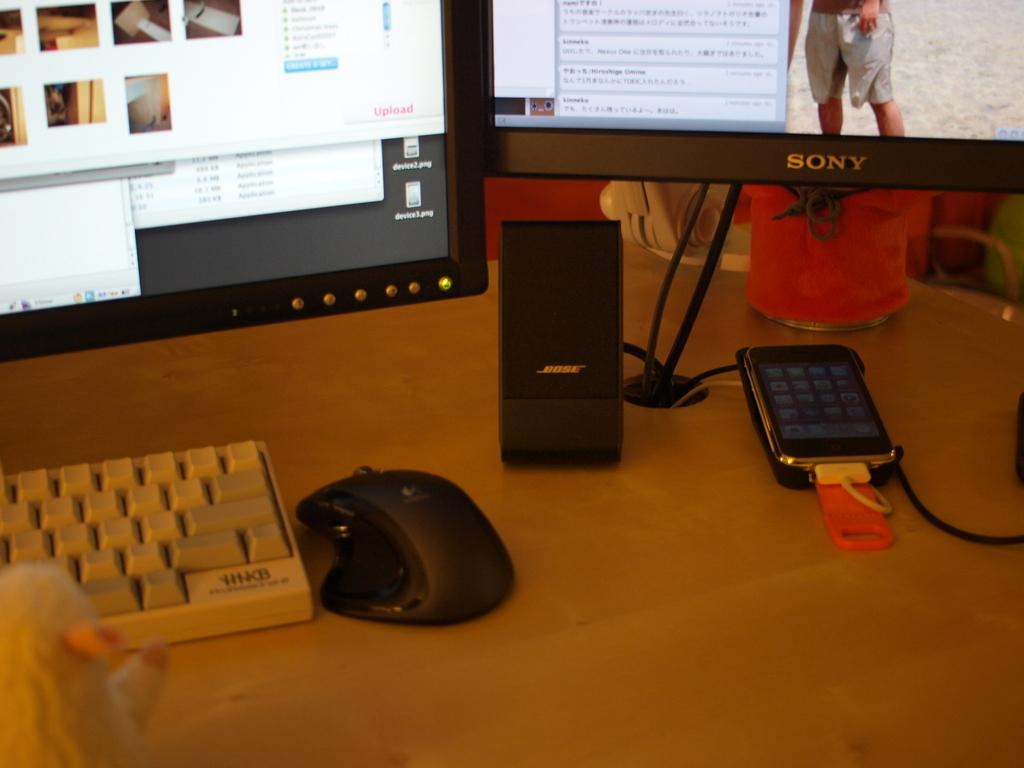What piece of furniture is present in the image? There is a table in the image. What electronic devices are on the table? There is a monitor, another screen, a keyboard, a mouse, and a mobile phone with wires on the table. What type of pain is the judge experiencing in the image? There is no judge or any indication of pain in the image; it features a table with electronic devices. How many nuts are visible on the table in the image? There are no nuts present in the image. 